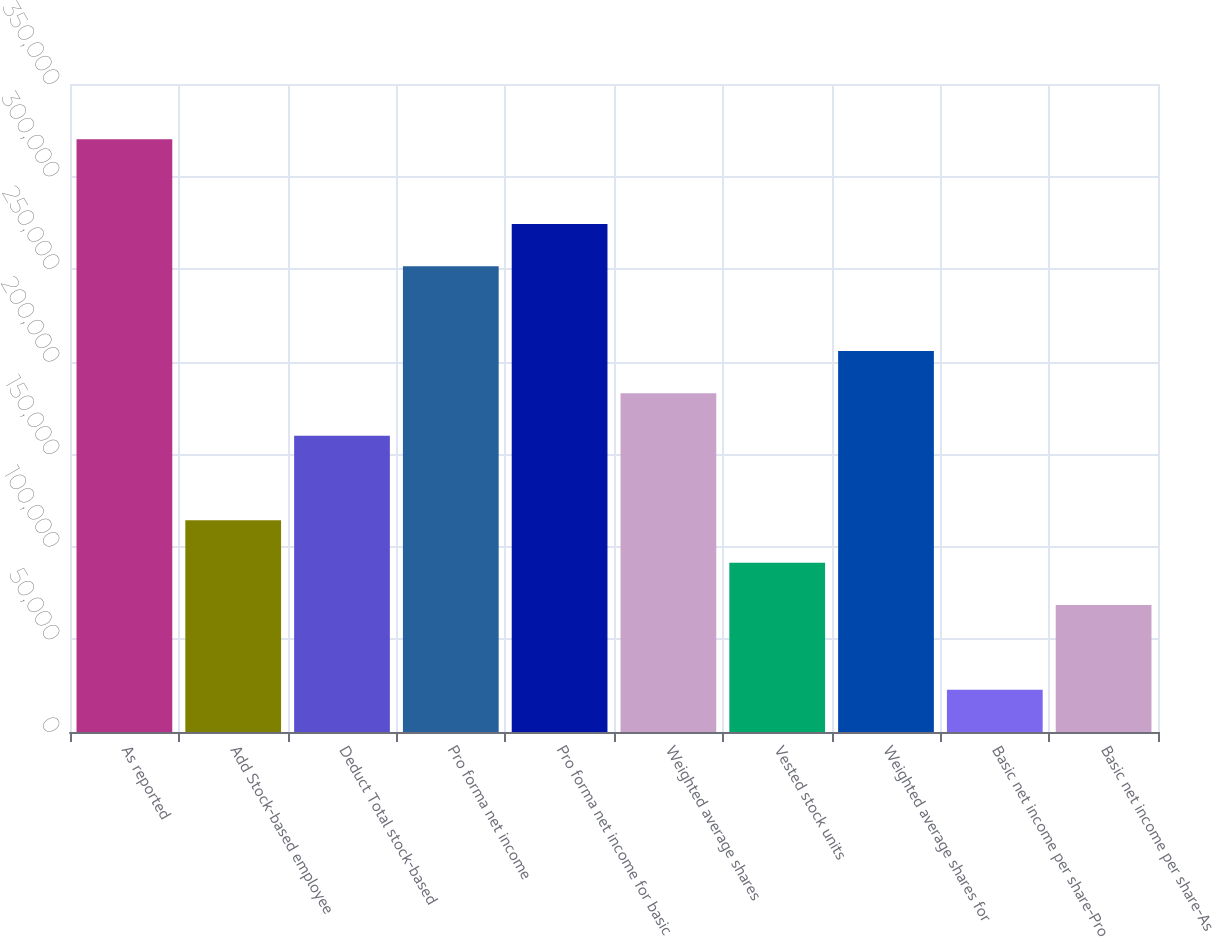Convert chart. <chart><loc_0><loc_0><loc_500><loc_500><bar_chart><fcel>As reported<fcel>Add Stock-based employee<fcel>Deduct Total stock-based<fcel>Pro forma net income<fcel>Pro forma net income for basic<fcel>Weighted average shares<fcel>Vested stock units<fcel>Weighted average shares for<fcel>Basic net income per share-Pro<fcel>Basic net income per share-As<nl><fcel>320099<fcel>114323<fcel>160051<fcel>251507<fcel>274371<fcel>182915<fcel>91458.5<fcel>205779<fcel>22866.2<fcel>68594.4<nl></chart> 